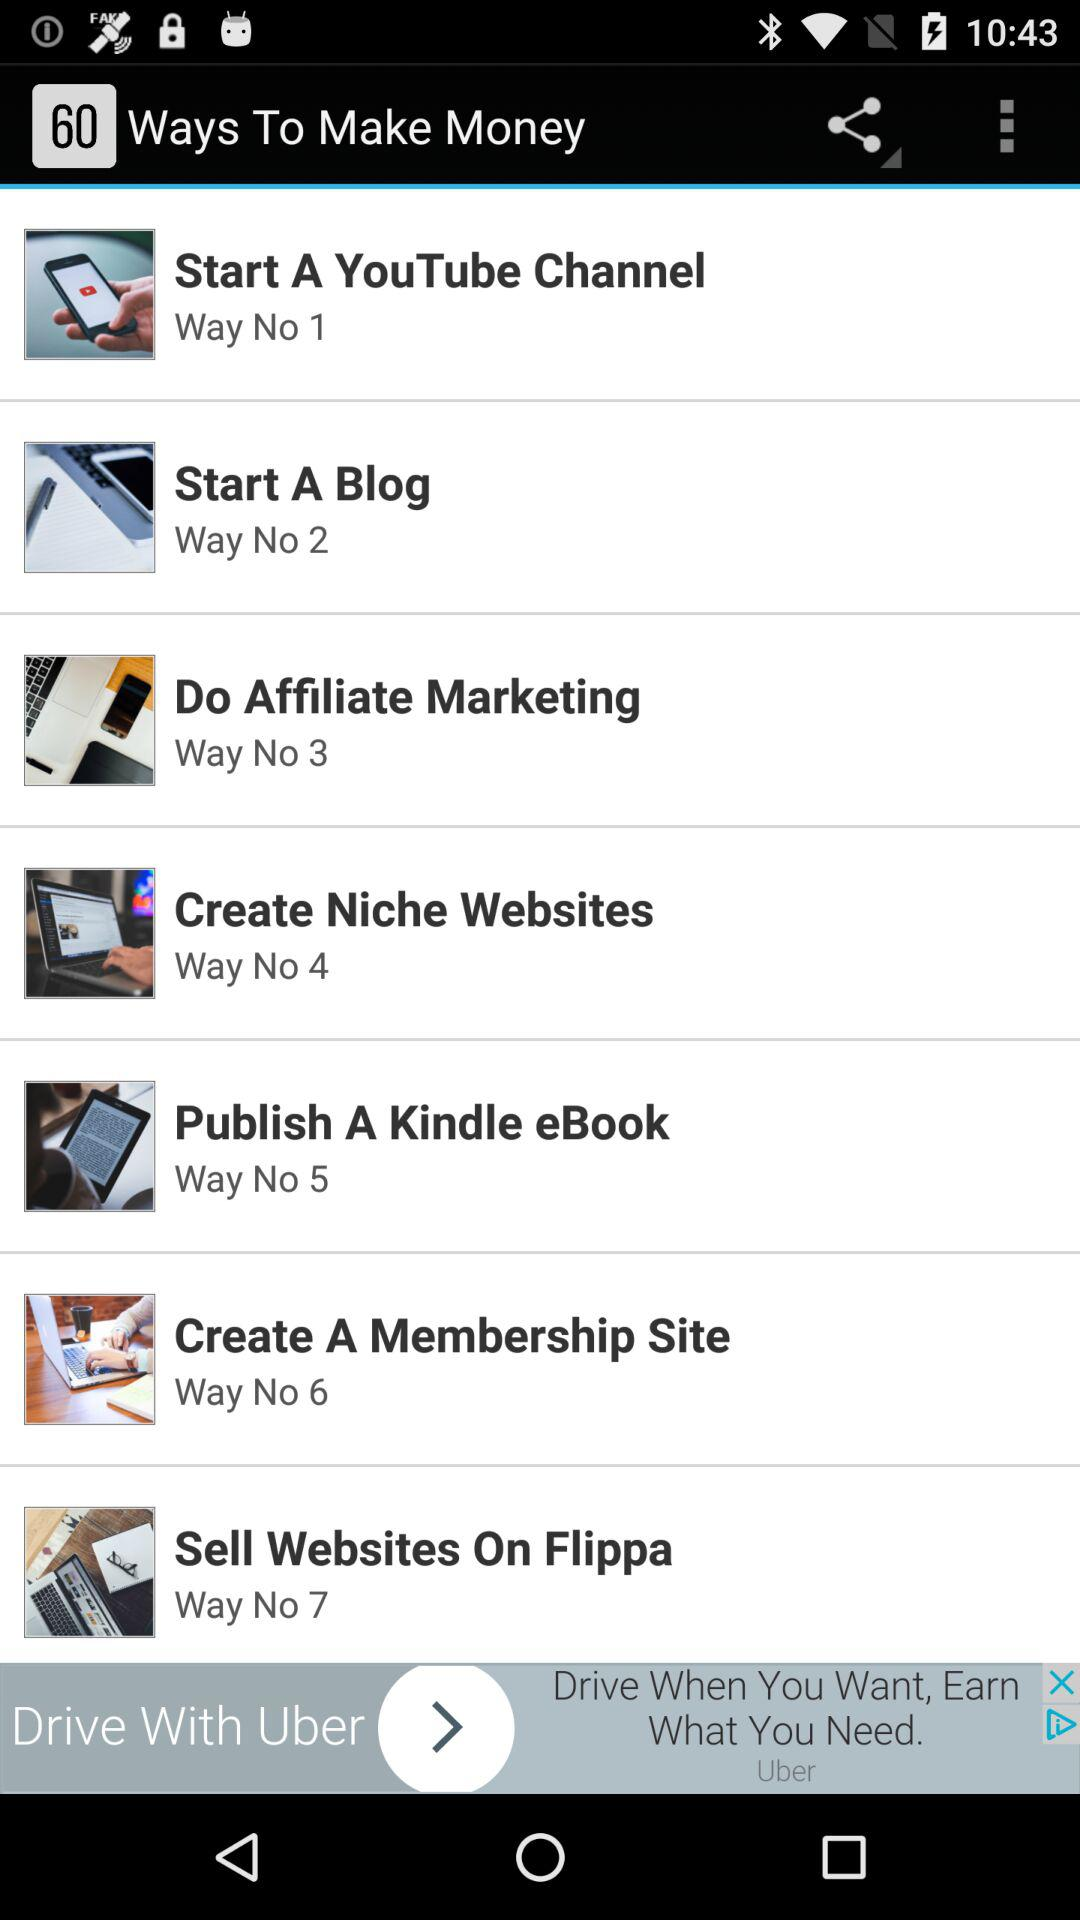Why is "Way No 4" used? "Way No 4" is used to make money. 